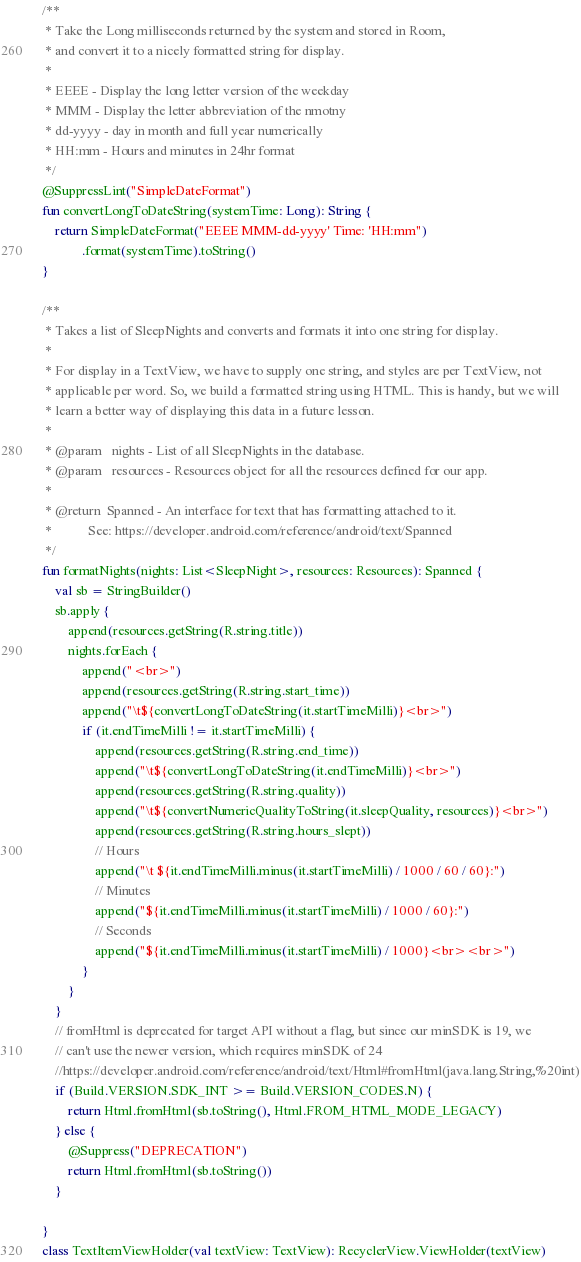<code> <loc_0><loc_0><loc_500><loc_500><_Kotlin_>

/**
 * Take the Long milliseconds returned by the system and stored in Room,
 * and convert it to a nicely formatted string for display.
 *
 * EEEE - Display the long letter version of the weekday
 * MMM - Display the letter abbreviation of the nmotny
 * dd-yyyy - day in month and full year numerically
 * HH:mm - Hours and minutes in 24hr format
 */
@SuppressLint("SimpleDateFormat")
fun convertLongToDateString(systemTime: Long): String {
    return SimpleDateFormat("EEEE MMM-dd-yyyy' Time: 'HH:mm")
            .format(systemTime).toString()
}

/**
 * Takes a list of SleepNights and converts and formats it into one string for display.
 *
 * For display in a TextView, we have to supply one string, and styles are per TextView, not
 * applicable per word. So, we build a formatted string using HTML. This is handy, but we will
 * learn a better way of displaying this data in a future lesson.
 *
 * @param   nights - List of all SleepNights in the database.
 * @param   resources - Resources object for all the resources defined for our app.
 *
 * @return  Spanned - An interface for text that has formatting attached to it.
 *           See: https://developer.android.com/reference/android/text/Spanned
 */
fun formatNights(nights: List<SleepNight>, resources: Resources): Spanned {
    val sb = StringBuilder()
    sb.apply {
        append(resources.getString(R.string.title))
        nights.forEach {
            append("<br>")
            append(resources.getString(R.string.start_time))
            append("\t${convertLongToDateString(it.startTimeMilli)}<br>")
            if (it.endTimeMilli != it.startTimeMilli) {
                append(resources.getString(R.string.end_time))
                append("\t${convertLongToDateString(it.endTimeMilli)}<br>")
                append(resources.getString(R.string.quality))
                append("\t${convertNumericQualityToString(it.sleepQuality, resources)}<br>")
                append(resources.getString(R.string.hours_slept))
                // Hours
                append("\t ${it.endTimeMilli.minus(it.startTimeMilli) / 1000 / 60 / 60}:")
                // Minutes
                append("${it.endTimeMilli.minus(it.startTimeMilli) / 1000 / 60}:")
                // Seconds
                append("${it.endTimeMilli.minus(it.startTimeMilli) / 1000}<br><br>")
            }
        }
    }
    // fromHtml is deprecated for target API without a flag, but since our minSDK is 19, we
    // can't use the newer version, which requires minSDK of 24
    //https://developer.android.com/reference/android/text/Html#fromHtml(java.lang.String,%20int)
    if (Build.VERSION.SDK_INT >= Build.VERSION_CODES.N) {
        return Html.fromHtml(sb.toString(), Html.FROM_HTML_MODE_LEGACY)
    } else {
        @Suppress("DEPRECATION")
        return Html.fromHtml(sb.toString())
    }

}
class TextItemViewHolder(val textView: TextView): RecyclerView.ViewHolder(textView)

</code> 